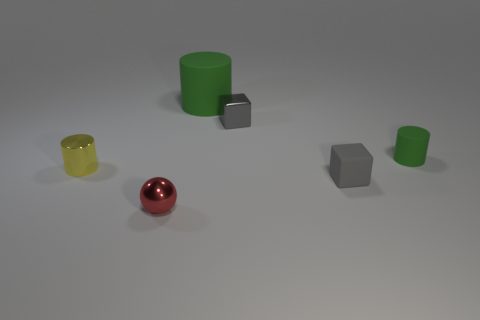There is another green cylinder that is the same material as the small green cylinder; what size is it?
Ensure brevity in your answer.  Large. How many small balls are the same color as the metallic cylinder?
Offer a terse response. 0. Is the number of small cylinders that are on the right side of the small yellow cylinder less than the number of small objects that are in front of the gray shiny cube?
Your response must be concise. Yes. There is a metal thing that is left of the small red metal object; is it the same shape as the red object?
Ensure brevity in your answer.  No. Is the small block that is in front of the tiny shiny cylinder made of the same material as the large green cylinder?
Make the answer very short. Yes. The cube in front of the green rubber cylinder right of the big green thing behind the tiny green cylinder is made of what material?
Provide a short and direct response. Rubber. How many other things are the same shape as the small yellow metal thing?
Offer a terse response. 2. What is the color of the tiny shiny cube that is behind the small gray rubber block?
Offer a terse response. Gray. What number of red metal balls are on the left side of the small gray cube that is behind the tiny block in front of the gray metallic thing?
Your answer should be very brief. 1. How many green matte things are behind the tiny thing that is behind the tiny green cylinder?
Your answer should be very brief. 1. 